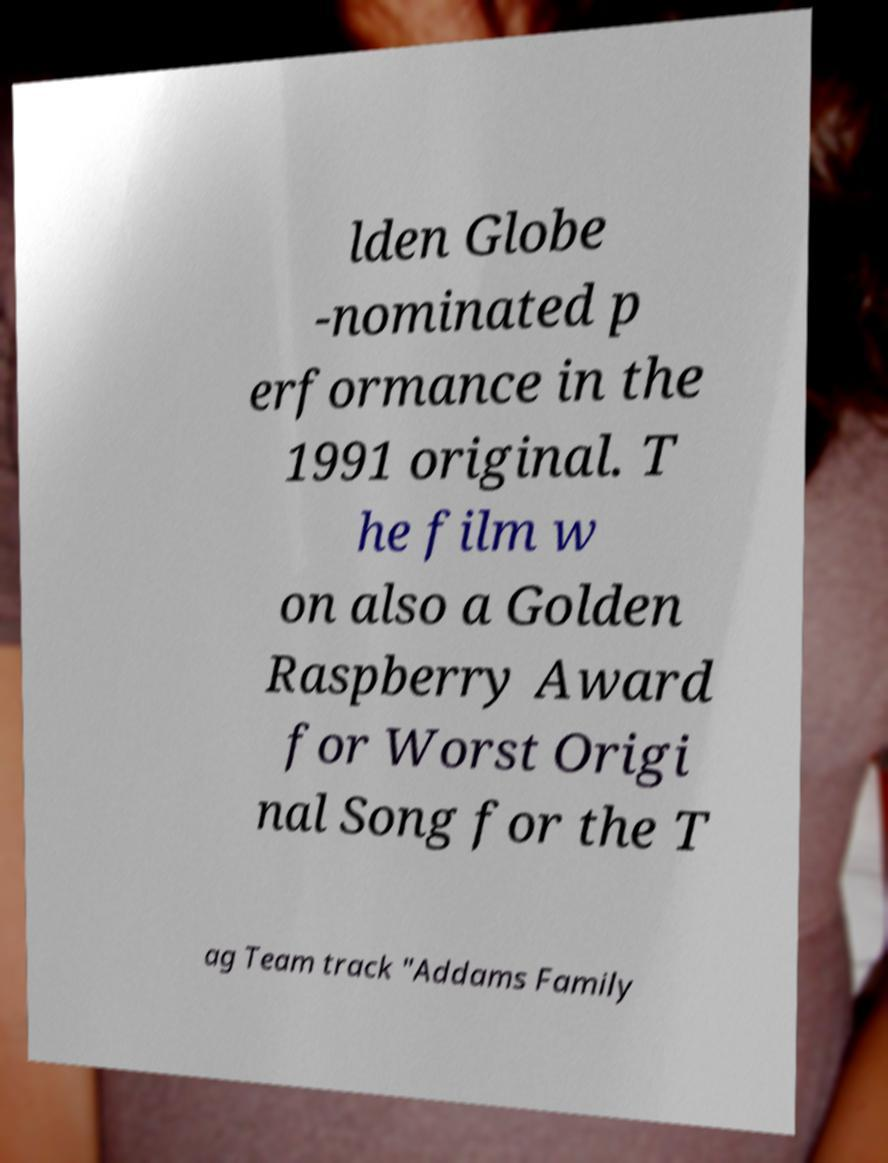Please read and relay the text visible in this image. What does it say? lden Globe -nominated p erformance in the 1991 original. T he film w on also a Golden Raspberry Award for Worst Origi nal Song for the T ag Team track "Addams Family 